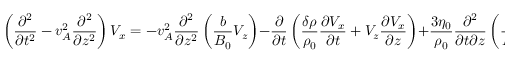<formula> <loc_0><loc_0><loc_500><loc_500>\left ( \frac { \partial ^ { 2 } } { \partial t ^ { 2 } } - v _ { A } ^ { 2 } \frac { \partial ^ { 2 } } { \partial z ^ { 2 } } \right ) V _ { x } = - v _ { A } ^ { 2 } \frac { \partial ^ { 2 } } { \partial z ^ { 2 } } \left ( \frac { b } { B _ { 0 } } V _ { z } \right ) - \frac { \partial } { \partial t } \left ( \frac { \delta \rho } { \rho _ { 0 } } \frac { \partial V _ { x } } { \partial t } + V _ { z } \frac { \partial V _ { x } } { \partial z } \right ) + \frac { 3 \eta _ { 0 } } { \rho _ { 0 } } \frac { \partial ^ { 2 } } { \partial t \partial z } \left ( \frac { b } { B _ { 0 } } \left [ \frac { b } { B _ { 0 } } \frac { \partial V _ { x } } { \partial z } + \frac { 2 } { 3 } \frac { \partial V _ { z } } { \partial z } \right ] \right ) + O ( \epsilon ^ { 5 / 2 } ) .</formula> 